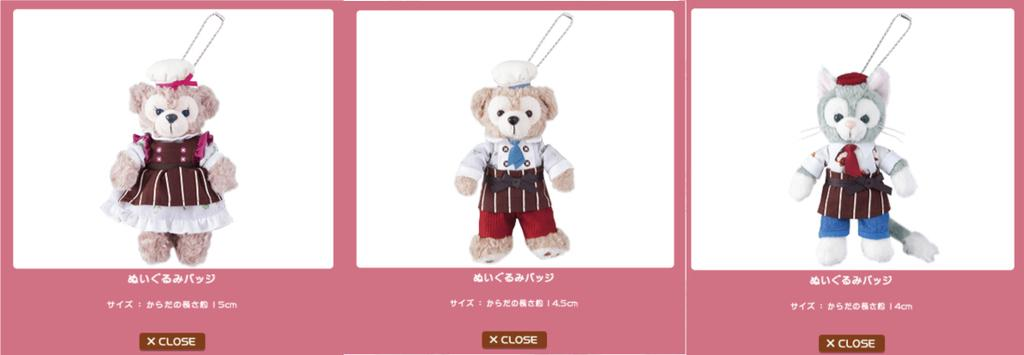What type of images are present in the image? There are pictures of teddy bears in the image. What force is being applied to the teddy bears in the image? There is no force being applied to the teddy bears in the image, as they are pictures and not physical objects. 